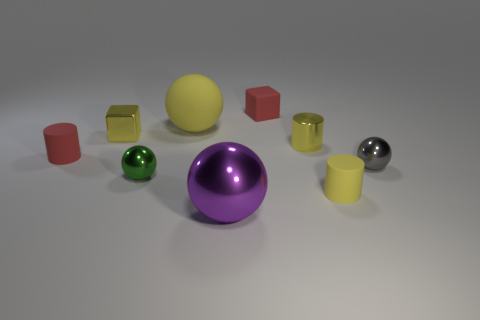Subtract all green blocks. How many yellow cylinders are left? 2 Subtract all shiny spheres. How many spheres are left? 1 Subtract 1 cylinders. How many cylinders are left? 2 Subtract all yellow cubes. How many cubes are left? 1 Subtract all cubes. How many objects are left? 7 Subtract all small yellow metallic cylinders. Subtract all small yellow cylinders. How many objects are left? 6 Add 7 small matte cubes. How many small matte cubes are left? 8 Add 5 small matte cylinders. How many small matte cylinders exist? 7 Subtract 0 purple cylinders. How many objects are left? 9 Subtract all red balls. Subtract all cyan cylinders. How many balls are left? 4 